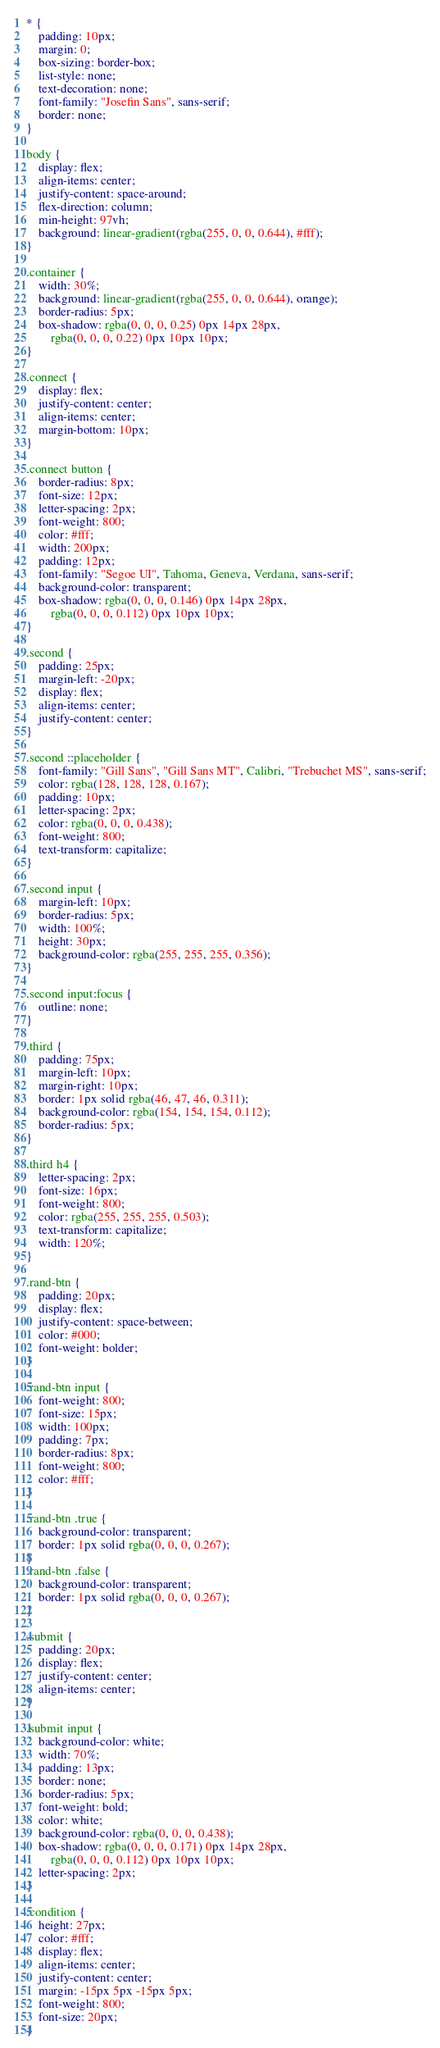Convert code to text. <code><loc_0><loc_0><loc_500><loc_500><_CSS_>* {
	padding: 10px;
	margin: 0;
	box-sizing: border-box;
	list-style: none;
	text-decoration: none;
	font-family: "Josefin Sans", sans-serif;
	border: none;
}

body {
	display: flex;
	align-items: center;
	justify-content: space-around;
	flex-direction: column;
	min-height: 97vh;
	background: linear-gradient(rgba(255, 0, 0, 0.644), #fff);
}

.container {
	width: 30%;
	background: linear-gradient(rgba(255, 0, 0, 0.644), orange);
	border-radius: 5px;
	box-shadow: rgba(0, 0, 0, 0.25) 0px 14px 28px,
		rgba(0, 0, 0, 0.22) 0px 10px 10px;
}

.connect {
	display: flex;
	justify-content: center;
	align-items: center;
	margin-bottom: 10px;
}

.connect button {
	border-radius: 8px;
	font-size: 12px;
	letter-spacing: 2px;
	font-weight: 800;
	color: #fff;
	width: 200px;
	padding: 12px;
	font-family: "Segoe UI", Tahoma, Geneva, Verdana, sans-serif;
	background-color: transparent;
	box-shadow: rgba(0, 0, 0, 0.146) 0px 14px 28px,
		rgba(0, 0, 0, 0.112) 0px 10px 10px;
}

.second {
	padding: 25px;
	margin-left: -20px;
	display: flex;
	align-items: center;
	justify-content: center;
}

.second ::placeholder {
	font-family: "Gill Sans", "Gill Sans MT", Calibri, "Trebuchet MS", sans-serif;
	color: rgba(128, 128, 128, 0.167);
	padding: 10px;
	letter-spacing: 2px;
	color: rgba(0, 0, 0, 0.438);
	font-weight: 800;
	text-transform: capitalize;
}

.second input {
	margin-left: 10px;
	border-radius: 5px;
	width: 100%;
	height: 30px;
	background-color: rgba(255, 255, 255, 0.356);
}

.second input:focus {
	outline: none;
}

.third {
	padding: 75px;
	margin-left: 10px;
	margin-right: 10px;
	border: 1px solid rgba(46, 47, 46, 0.311);
	background-color: rgba(154, 154, 154, 0.112);
	border-radius: 5px;
}

.third h4 {
	letter-spacing: 2px;
	font-size: 16px;
	font-weight: 800;
	color: rgba(255, 255, 255, 0.503);
	text-transform: capitalize;
	width: 120%;
}

.rand-btn {
	padding: 20px;
	display: flex;
	justify-content: space-between;
	color: #000;
	font-weight: bolder;
}

.rand-btn input {
	font-weight: 800;
	font-size: 15px;
	width: 100px;
	padding: 7px;
	border-radius: 8px;
	font-weight: 800;
	color: #fff;
}

.rand-btn .true {
	background-color: transparent;
	border: 1px solid rgba(0, 0, 0, 0.267);
}
.rand-btn .false {
	background-color: transparent;
	border: 1px solid rgba(0, 0, 0, 0.267);
}

.submit {
	padding: 20px;
	display: flex;
	justify-content: center;
	align-items: center;
}

.submit input {
	background-color: white;
	width: 70%;
	padding: 13px;
	border: none;
	border-radius: 5px;
	font-weight: bold;
	color: white;
	background-color: rgba(0, 0, 0, 0.438);
	box-shadow: rgba(0, 0, 0, 0.171) 0px 14px 28px,
		rgba(0, 0, 0, 0.112) 0px 10px 10px;
	letter-spacing: 2px;
}

.condition {
	height: 27px;
	color: #fff;
	display: flex;
	align-items: center;
	justify-content: center;
	margin: -15px 5px -15px 5px;
	font-weight: 800;
	font-size: 20px;
}
</code> 